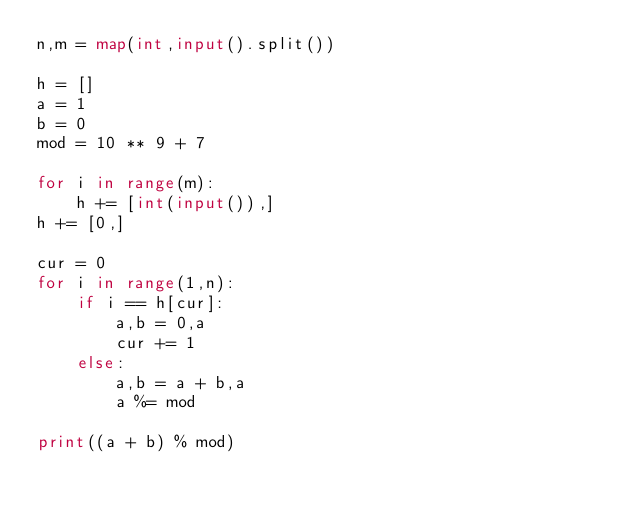<code> <loc_0><loc_0><loc_500><loc_500><_Python_>n,m = map(int,input().split())
 
h = []
a = 1
b = 0
mod = 10 ** 9 + 7
 
for i in range(m):
    h += [int(input()),]
h += [0,]
    
cur = 0
for i in range(1,n):
    if i == h[cur]:
        a,b = 0,a
        cur += 1
    else:
        a,b = a + b,a
        a %= mod

print((a + b) % mod)</code> 